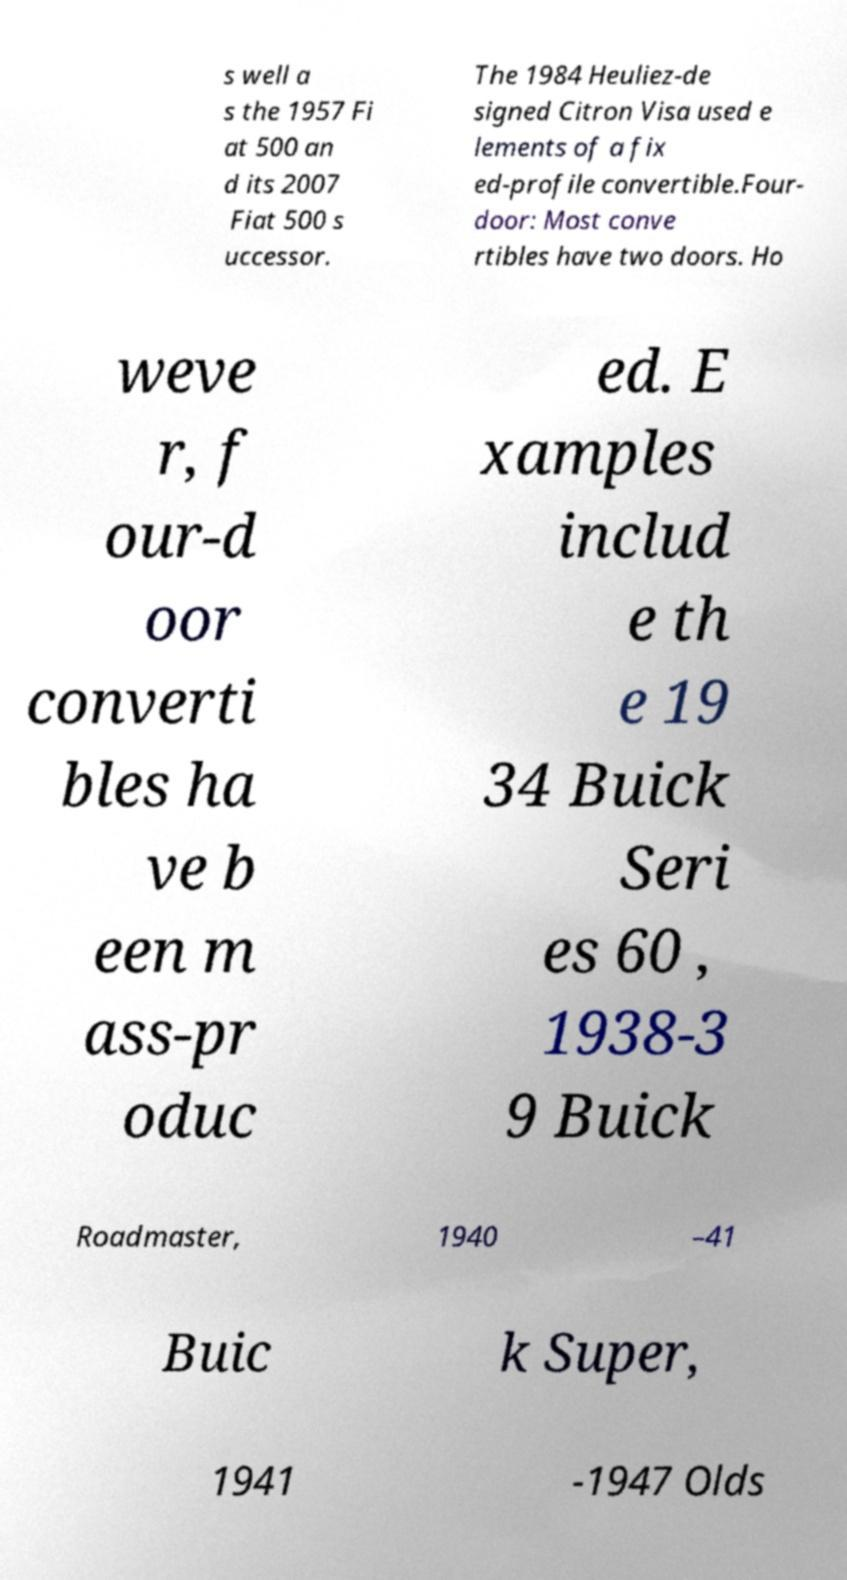Please identify and transcribe the text found in this image. s well a s the 1957 Fi at 500 an d its 2007 Fiat 500 s uccessor. The 1984 Heuliez-de signed Citron Visa used e lements of a fix ed-profile convertible.Four- door: Most conve rtibles have two doors. Ho weve r, f our-d oor converti bles ha ve b een m ass-pr oduc ed. E xamples includ e th e 19 34 Buick Seri es 60 , 1938-3 9 Buick Roadmaster, 1940 –41 Buic k Super, 1941 -1947 Olds 